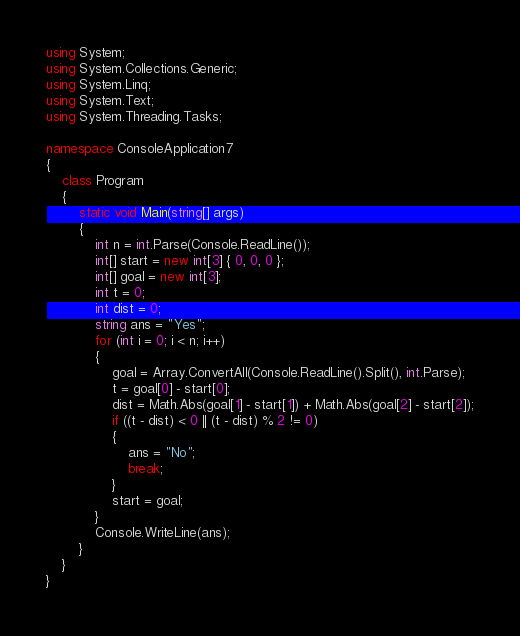Convert code to text. <code><loc_0><loc_0><loc_500><loc_500><_C#_>using System;
using System.Collections.Generic;
using System.Linq;
using System.Text;
using System.Threading.Tasks;
 
namespace ConsoleApplication7
{
    class Program
    {
        static void Main(string[] args)
        {
            int n = int.Parse(Console.ReadLine());
            int[] start = new int[3] { 0, 0, 0 };
            int[] goal = new int[3];
            int t = 0;
            int dist = 0;
            string ans = "Yes";
            for (int i = 0; i < n; i++)
            {
                goal = Array.ConvertAll(Console.ReadLine().Split(), int.Parse);
                t = goal[0] - start[0];
                dist = Math.Abs(goal[1] - start[1]) + Math.Abs(goal[2] - start[2]);
                if ((t - dist) < 0 || (t - dist) % 2 != 0)
                {
                    ans = "No";
                    break;
                }
                start = goal;
            }
            Console.WriteLine(ans);
        }
    }
}</code> 